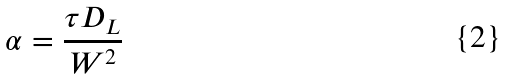<formula> <loc_0><loc_0><loc_500><loc_500>\alpha = \frac { \tau D _ { L } } { W ^ { 2 } }</formula> 